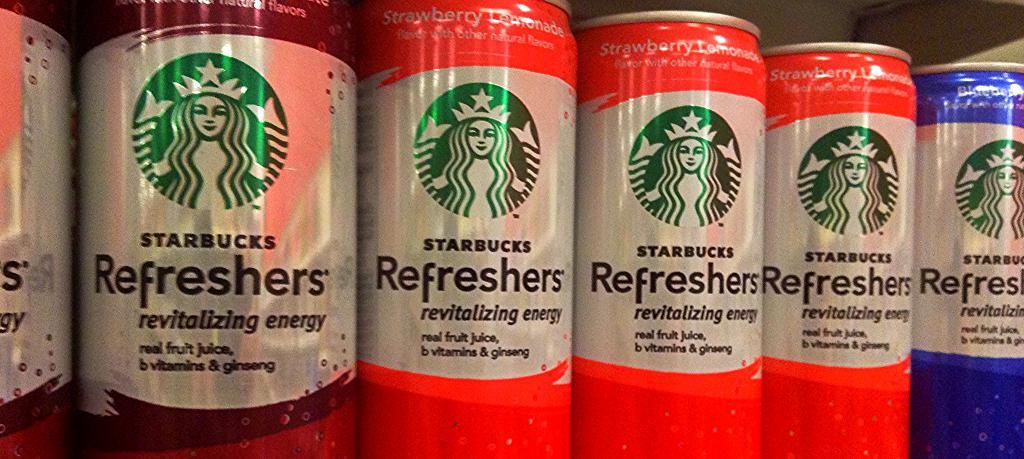<image>
Write a terse but informative summary of the picture. Several cans of Starbucks Refreshers, including Strawberry Lemonade. 